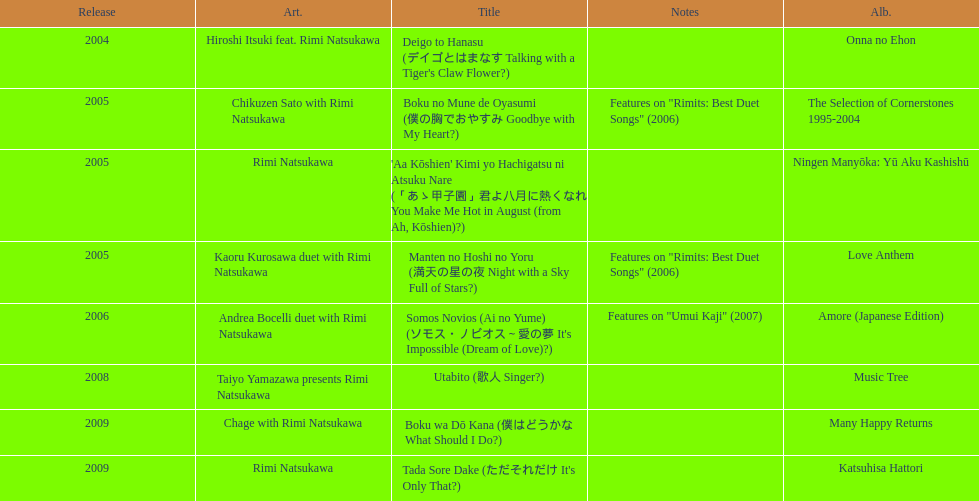What was the album released immediately before the one that had boku wa do kana on it? Music Tree. 